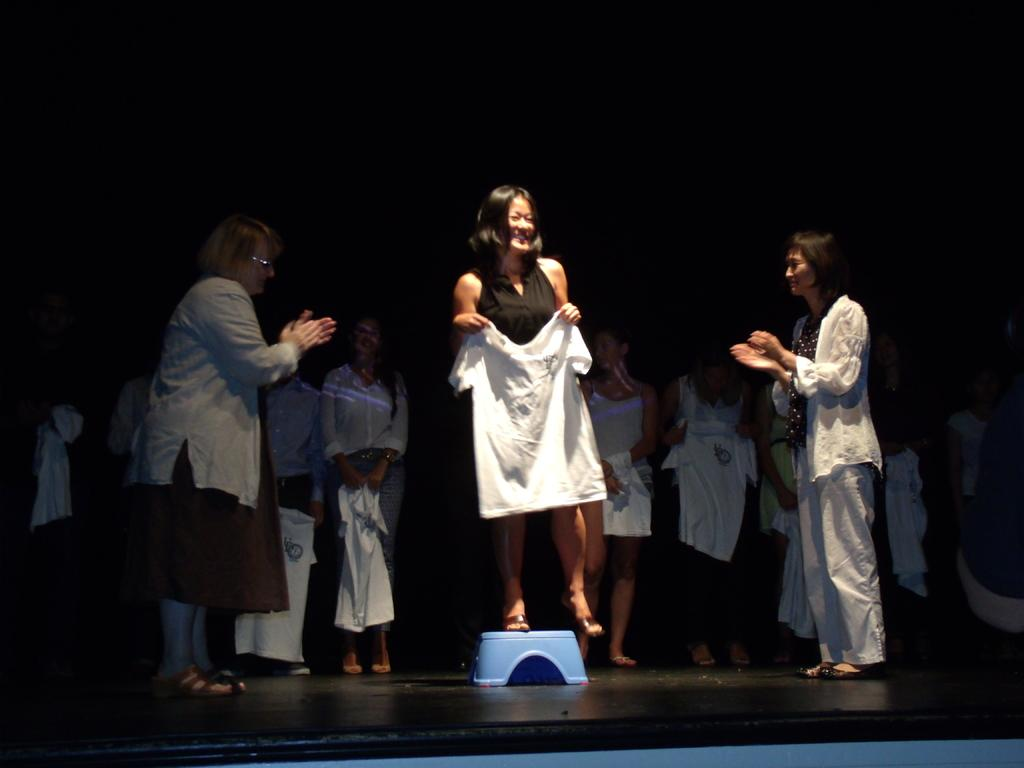How many people are in the image? There is a group of people in the image. Where are the people standing? The people are standing on a path. What is the woman doing in the image? The woman is standing on a stool and holding a white t-shirt. What is the color of the background in the image? The background of the image is dark. How many frogs can be seen hopping on the path in the image? There are no frogs visible in the image; it features a group of people standing on a path. What type of worm is crawling on the woman's arm in the image? There is no worm present in the image; the woman is holding a white t-shirt while standing on a stool. 